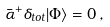<formula> <loc_0><loc_0><loc_500><loc_500>\bar { \alpha } ^ { + } \delta _ { t o t } | \Phi \rangle = 0 \, ,</formula> 